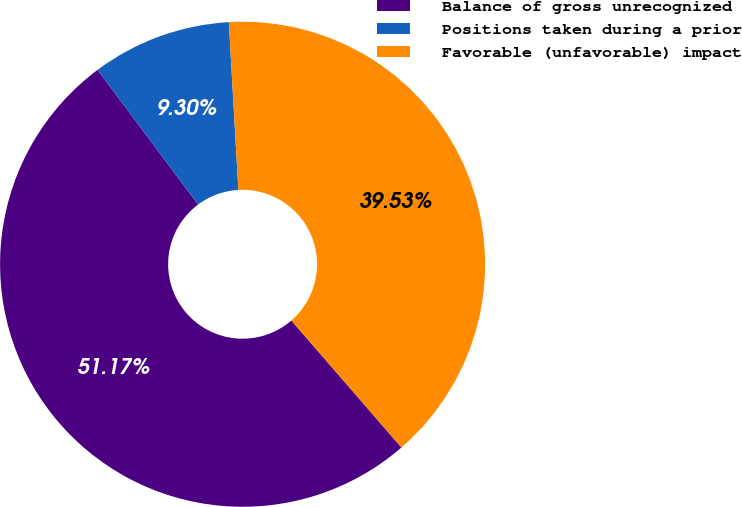Convert chart to OTSL. <chart><loc_0><loc_0><loc_500><loc_500><pie_chart><fcel>Balance of gross unrecognized<fcel>Positions taken during a prior<fcel>Favorable (unfavorable) impact<nl><fcel>51.16%<fcel>9.3%<fcel>39.53%<nl></chart> 